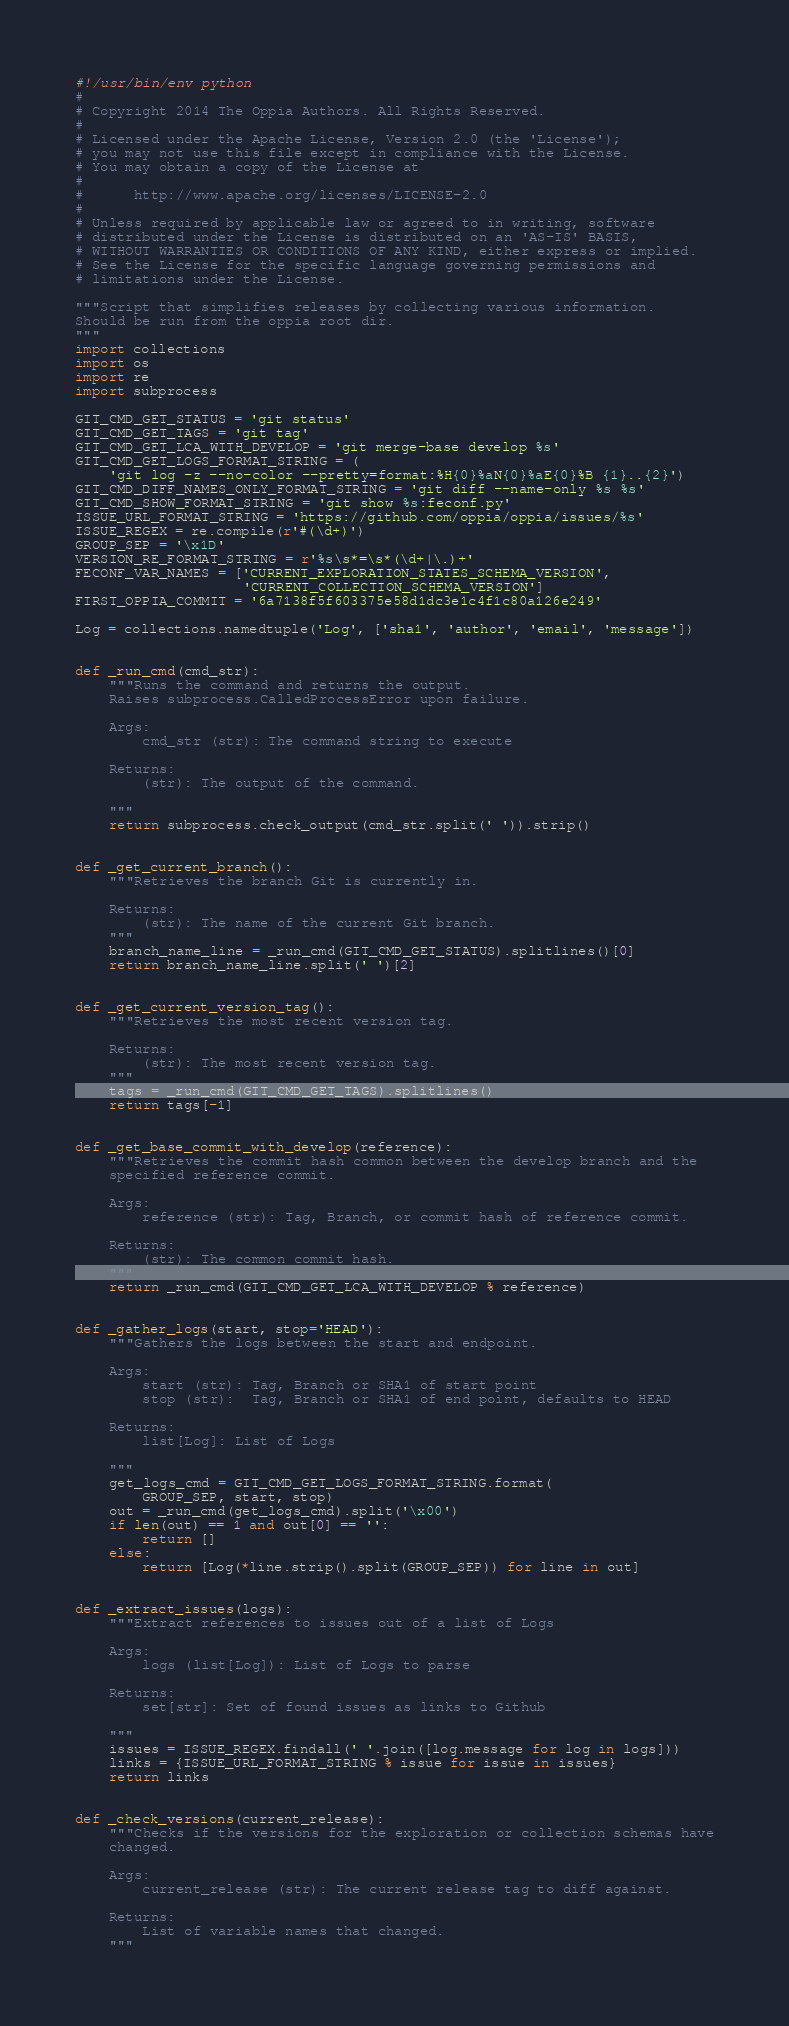Convert code to text. <code><loc_0><loc_0><loc_500><loc_500><_Python_>#!/usr/bin/env python
#
# Copyright 2014 The Oppia Authors. All Rights Reserved.
#
# Licensed under the Apache License, Version 2.0 (the 'License');
# you may not use this file except in compliance with the License.
# You may obtain a copy of the License at
#
#      http://www.apache.org/licenses/LICENSE-2.0
#
# Unless required by applicable law or agreed to in writing, software
# distributed under the License is distributed on an 'AS-IS' BASIS,
# WITHOUT WARRANTIES OR CONDITIONS OF ANY KIND, either express or implied.
# See the License for the specific language governing permissions and
# limitations under the License.

"""Script that simplifies releases by collecting various information.
Should be run from the oppia root dir.
"""
import collections
import os
import re
import subprocess

GIT_CMD_GET_STATUS = 'git status'
GIT_CMD_GET_TAGS = 'git tag'
GIT_CMD_GET_LCA_WITH_DEVELOP = 'git merge-base develop %s'
GIT_CMD_GET_LOGS_FORMAT_STRING = (
    'git log -z --no-color --pretty=format:%H{0}%aN{0}%aE{0}%B {1}..{2}')
GIT_CMD_DIFF_NAMES_ONLY_FORMAT_STRING = 'git diff --name-only %s %s'
GIT_CMD_SHOW_FORMAT_STRING = 'git show %s:feconf.py'
ISSUE_URL_FORMAT_STRING = 'https://github.com/oppia/oppia/issues/%s'
ISSUE_REGEX = re.compile(r'#(\d+)')
GROUP_SEP = '\x1D'
VERSION_RE_FORMAT_STRING = r'%s\s*=\s*(\d+|\.)+'
FECONF_VAR_NAMES = ['CURRENT_EXPLORATION_STATES_SCHEMA_VERSION',
                    'CURRENT_COLLECTION_SCHEMA_VERSION']
FIRST_OPPIA_COMMIT = '6a7138f5f603375e58d1dc3e1c4f1c80a126e249'

Log = collections.namedtuple('Log', ['sha1', 'author', 'email', 'message'])


def _run_cmd(cmd_str):
    """Runs the command and returns the output.
    Raises subprocess.CalledProcessError upon failure.

    Args:
        cmd_str (str): The command string to execute

    Returns:
        (str): The output of the command.

    """
    return subprocess.check_output(cmd_str.split(' ')).strip()


def _get_current_branch():
    """Retrieves the branch Git is currently in.

    Returns:
        (str): The name of the current Git branch.
    """
    branch_name_line = _run_cmd(GIT_CMD_GET_STATUS).splitlines()[0]
    return branch_name_line.split(' ')[2]


def _get_current_version_tag():
    """Retrieves the most recent version tag.

    Returns:
        (str): The most recent version tag.
    """
    tags = _run_cmd(GIT_CMD_GET_TAGS).splitlines()
    return tags[-1]


def _get_base_commit_with_develop(reference):
    """Retrieves the commit hash common between the develop branch and the
    specified reference commit.

    Args:
        reference (str): Tag, Branch, or commit hash of reference commit.

    Returns:
        (str): The common commit hash.
    """
    return _run_cmd(GIT_CMD_GET_LCA_WITH_DEVELOP % reference)


def _gather_logs(start, stop='HEAD'):
    """Gathers the logs between the start and endpoint.

    Args:
        start (str): Tag, Branch or SHA1 of start point
        stop (str):  Tag, Branch or SHA1 of end point, defaults to HEAD

    Returns:
        list[Log]: List of Logs

    """
    get_logs_cmd = GIT_CMD_GET_LOGS_FORMAT_STRING.format(
        GROUP_SEP, start, stop)
    out = _run_cmd(get_logs_cmd).split('\x00')
    if len(out) == 1 and out[0] == '':
        return []
    else:
        return [Log(*line.strip().split(GROUP_SEP)) for line in out]


def _extract_issues(logs):
    """Extract references to issues out of a list of Logs

    Args:
        logs (list[Log]): List of Logs to parse

    Returns:
        set[str]: Set of found issues as links to Github

    """
    issues = ISSUE_REGEX.findall(' '.join([log.message for log in logs]))
    links = {ISSUE_URL_FORMAT_STRING % issue for issue in issues}
    return links


def _check_versions(current_release):
    """Checks if the versions for the exploration or collection schemas have
    changed.

    Args:
        current_release (str): The current release tag to diff against.

    Returns:
        List of variable names that changed.
    """</code> 